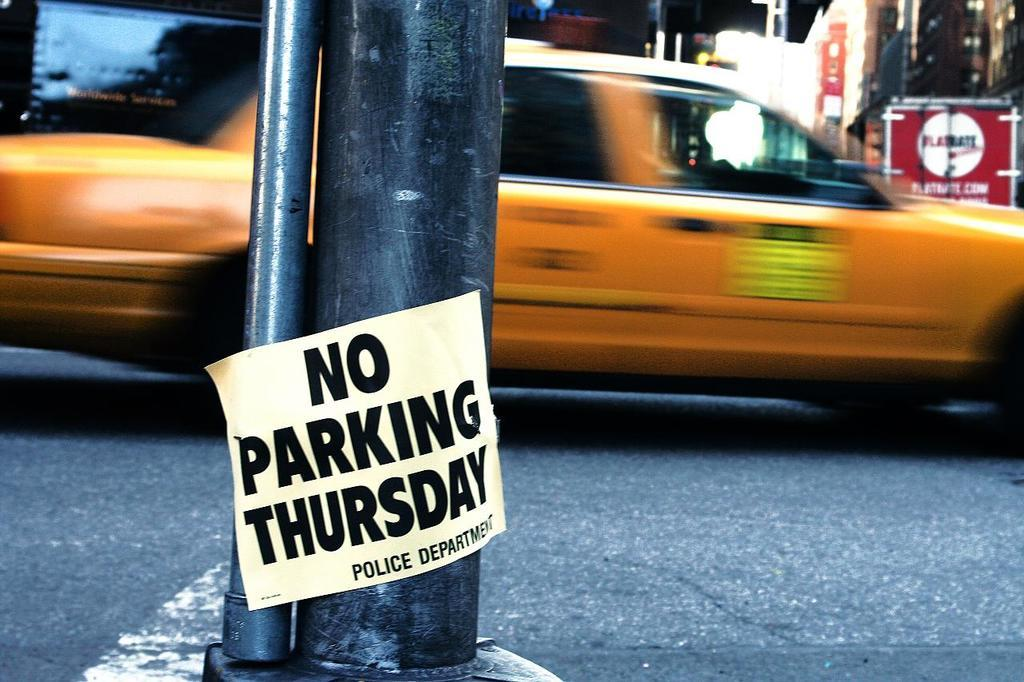<image>
Summarize the visual content of the image. A pole on the street stating no parking is allowed on Thursdays. 